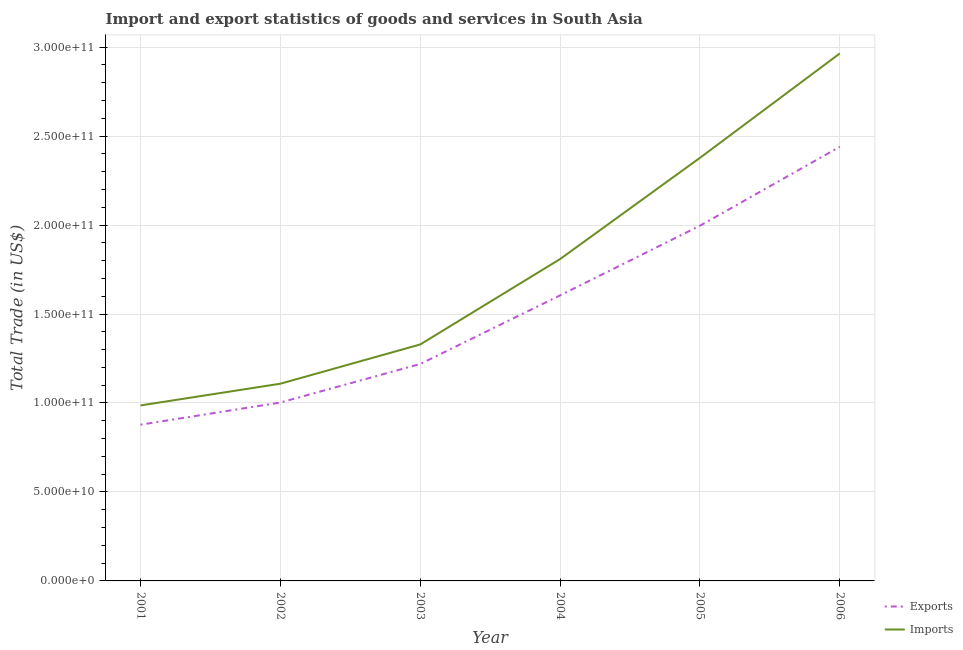How many different coloured lines are there?
Your answer should be compact. 2. Does the line corresponding to imports of goods and services intersect with the line corresponding to export of goods and services?
Keep it short and to the point. No. Is the number of lines equal to the number of legend labels?
Provide a succinct answer. Yes. What is the imports of goods and services in 2002?
Make the answer very short. 1.11e+11. Across all years, what is the maximum imports of goods and services?
Offer a very short reply. 2.96e+11. Across all years, what is the minimum imports of goods and services?
Offer a very short reply. 9.86e+1. In which year was the imports of goods and services maximum?
Your answer should be very brief. 2006. What is the total imports of goods and services in the graph?
Your answer should be compact. 1.06e+12. What is the difference between the imports of goods and services in 2001 and that in 2002?
Offer a very short reply. -1.22e+1. What is the difference between the export of goods and services in 2005 and the imports of goods and services in 2003?
Ensure brevity in your answer.  6.67e+1. What is the average export of goods and services per year?
Make the answer very short. 1.52e+11. In the year 2006, what is the difference between the export of goods and services and imports of goods and services?
Ensure brevity in your answer.  -5.24e+1. What is the ratio of the imports of goods and services in 2001 to that in 2005?
Provide a short and direct response. 0.41. Is the imports of goods and services in 2001 less than that in 2003?
Ensure brevity in your answer.  Yes. Is the difference between the imports of goods and services in 2004 and 2005 greater than the difference between the export of goods and services in 2004 and 2005?
Offer a terse response. No. What is the difference between the highest and the second highest imports of goods and services?
Keep it short and to the point. 5.87e+1. What is the difference between the highest and the lowest imports of goods and services?
Give a very brief answer. 1.98e+11. Does the export of goods and services monotonically increase over the years?
Give a very brief answer. Yes. Are the values on the major ticks of Y-axis written in scientific E-notation?
Offer a terse response. Yes. How are the legend labels stacked?
Give a very brief answer. Vertical. What is the title of the graph?
Give a very brief answer. Import and export statistics of goods and services in South Asia. What is the label or title of the X-axis?
Offer a very short reply. Year. What is the label or title of the Y-axis?
Your answer should be very brief. Total Trade (in US$). What is the Total Trade (in US$) in Exports in 2001?
Provide a short and direct response. 8.78e+1. What is the Total Trade (in US$) in Imports in 2001?
Your answer should be very brief. 9.86e+1. What is the Total Trade (in US$) in Exports in 2002?
Provide a succinct answer. 1.00e+11. What is the Total Trade (in US$) of Imports in 2002?
Provide a short and direct response. 1.11e+11. What is the Total Trade (in US$) in Exports in 2003?
Ensure brevity in your answer.  1.22e+11. What is the Total Trade (in US$) in Imports in 2003?
Make the answer very short. 1.33e+11. What is the Total Trade (in US$) of Exports in 2004?
Your response must be concise. 1.60e+11. What is the Total Trade (in US$) in Imports in 2004?
Make the answer very short. 1.81e+11. What is the Total Trade (in US$) of Exports in 2005?
Your answer should be very brief. 2.00e+11. What is the Total Trade (in US$) in Imports in 2005?
Ensure brevity in your answer.  2.38e+11. What is the Total Trade (in US$) in Exports in 2006?
Keep it short and to the point. 2.44e+11. What is the Total Trade (in US$) of Imports in 2006?
Provide a succinct answer. 2.96e+11. Across all years, what is the maximum Total Trade (in US$) of Exports?
Your answer should be very brief. 2.44e+11. Across all years, what is the maximum Total Trade (in US$) of Imports?
Provide a succinct answer. 2.96e+11. Across all years, what is the minimum Total Trade (in US$) in Exports?
Ensure brevity in your answer.  8.78e+1. Across all years, what is the minimum Total Trade (in US$) of Imports?
Your response must be concise. 9.86e+1. What is the total Total Trade (in US$) in Exports in the graph?
Offer a very short reply. 9.14e+11. What is the total Total Trade (in US$) of Imports in the graph?
Your answer should be compact. 1.06e+12. What is the difference between the Total Trade (in US$) in Exports in 2001 and that in 2002?
Keep it short and to the point. -1.25e+1. What is the difference between the Total Trade (in US$) of Imports in 2001 and that in 2002?
Provide a short and direct response. -1.22e+1. What is the difference between the Total Trade (in US$) in Exports in 2001 and that in 2003?
Offer a terse response. -3.41e+1. What is the difference between the Total Trade (in US$) of Imports in 2001 and that in 2003?
Your response must be concise. -3.43e+1. What is the difference between the Total Trade (in US$) of Exports in 2001 and that in 2004?
Your answer should be compact. -7.27e+1. What is the difference between the Total Trade (in US$) in Imports in 2001 and that in 2004?
Make the answer very short. -8.23e+1. What is the difference between the Total Trade (in US$) in Exports in 2001 and that in 2005?
Make the answer very short. -1.12e+11. What is the difference between the Total Trade (in US$) in Imports in 2001 and that in 2005?
Offer a very short reply. -1.39e+11. What is the difference between the Total Trade (in US$) of Exports in 2001 and that in 2006?
Keep it short and to the point. -1.56e+11. What is the difference between the Total Trade (in US$) of Imports in 2001 and that in 2006?
Ensure brevity in your answer.  -1.98e+11. What is the difference between the Total Trade (in US$) of Exports in 2002 and that in 2003?
Ensure brevity in your answer.  -2.17e+1. What is the difference between the Total Trade (in US$) of Imports in 2002 and that in 2003?
Make the answer very short. -2.20e+1. What is the difference between the Total Trade (in US$) of Exports in 2002 and that in 2004?
Ensure brevity in your answer.  -6.02e+1. What is the difference between the Total Trade (in US$) of Imports in 2002 and that in 2004?
Ensure brevity in your answer.  -7.00e+1. What is the difference between the Total Trade (in US$) in Exports in 2002 and that in 2005?
Your answer should be very brief. -9.93e+1. What is the difference between the Total Trade (in US$) in Imports in 2002 and that in 2005?
Keep it short and to the point. -1.27e+11. What is the difference between the Total Trade (in US$) in Exports in 2002 and that in 2006?
Offer a very short reply. -1.44e+11. What is the difference between the Total Trade (in US$) in Imports in 2002 and that in 2006?
Your answer should be compact. -1.86e+11. What is the difference between the Total Trade (in US$) of Exports in 2003 and that in 2004?
Your response must be concise. -3.86e+1. What is the difference between the Total Trade (in US$) in Imports in 2003 and that in 2004?
Make the answer very short. -4.80e+1. What is the difference between the Total Trade (in US$) of Exports in 2003 and that in 2005?
Provide a succinct answer. -7.77e+1. What is the difference between the Total Trade (in US$) in Imports in 2003 and that in 2005?
Ensure brevity in your answer.  -1.05e+11. What is the difference between the Total Trade (in US$) in Exports in 2003 and that in 2006?
Keep it short and to the point. -1.22e+11. What is the difference between the Total Trade (in US$) in Imports in 2003 and that in 2006?
Offer a terse response. -1.64e+11. What is the difference between the Total Trade (in US$) in Exports in 2004 and that in 2005?
Provide a succinct answer. -3.91e+1. What is the difference between the Total Trade (in US$) of Imports in 2004 and that in 2005?
Give a very brief answer. -5.69e+1. What is the difference between the Total Trade (in US$) of Exports in 2004 and that in 2006?
Make the answer very short. -8.35e+1. What is the difference between the Total Trade (in US$) in Imports in 2004 and that in 2006?
Your response must be concise. -1.16e+11. What is the difference between the Total Trade (in US$) in Exports in 2005 and that in 2006?
Your answer should be compact. -4.44e+1. What is the difference between the Total Trade (in US$) of Imports in 2005 and that in 2006?
Offer a very short reply. -5.87e+1. What is the difference between the Total Trade (in US$) in Exports in 2001 and the Total Trade (in US$) in Imports in 2002?
Offer a very short reply. -2.30e+1. What is the difference between the Total Trade (in US$) in Exports in 2001 and the Total Trade (in US$) in Imports in 2003?
Ensure brevity in your answer.  -4.51e+1. What is the difference between the Total Trade (in US$) of Exports in 2001 and the Total Trade (in US$) of Imports in 2004?
Your answer should be very brief. -9.31e+1. What is the difference between the Total Trade (in US$) in Exports in 2001 and the Total Trade (in US$) in Imports in 2005?
Keep it short and to the point. -1.50e+11. What is the difference between the Total Trade (in US$) of Exports in 2001 and the Total Trade (in US$) of Imports in 2006?
Your answer should be compact. -2.09e+11. What is the difference between the Total Trade (in US$) in Exports in 2002 and the Total Trade (in US$) in Imports in 2003?
Offer a terse response. -3.26e+1. What is the difference between the Total Trade (in US$) of Exports in 2002 and the Total Trade (in US$) of Imports in 2004?
Provide a short and direct response. -8.06e+1. What is the difference between the Total Trade (in US$) of Exports in 2002 and the Total Trade (in US$) of Imports in 2005?
Keep it short and to the point. -1.38e+11. What is the difference between the Total Trade (in US$) of Exports in 2002 and the Total Trade (in US$) of Imports in 2006?
Give a very brief answer. -1.96e+11. What is the difference between the Total Trade (in US$) in Exports in 2003 and the Total Trade (in US$) in Imports in 2004?
Offer a very short reply. -5.90e+1. What is the difference between the Total Trade (in US$) in Exports in 2003 and the Total Trade (in US$) in Imports in 2005?
Give a very brief answer. -1.16e+11. What is the difference between the Total Trade (in US$) of Exports in 2003 and the Total Trade (in US$) of Imports in 2006?
Your answer should be very brief. -1.75e+11. What is the difference between the Total Trade (in US$) in Exports in 2004 and the Total Trade (in US$) in Imports in 2005?
Offer a terse response. -7.73e+1. What is the difference between the Total Trade (in US$) in Exports in 2004 and the Total Trade (in US$) in Imports in 2006?
Offer a terse response. -1.36e+11. What is the difference between the Total Trade (in US$) of Exports in 2005 and the Total Trade (in US$) of Imports in 2006?
Your answer should be very brief. -9.68e+1. What is the average Total Trade (in US$) in Exports per year?
Your answer should be very brief. 1.52e+11. What is the average Total Trade (in US$) of Imports per year?
Provide a short and direct response. 1.76e+11. In the year 2001, what is the difference between the Total Trade (in US$) in Exports and Total Trade (in US$) in Imports?
Give a very brief answer. -1.08e+1. In the year 2002, what is the difference between the Total Trade (in US$) of Exports and Total Trade (in US$) of Imports?
Your answer should be very brief. -1.06e+1. In the year 2003, what is the difference between the Total Trade (in US$) in Exports and Total Trade (in US$) in Imports?
Your answer should be compact. -1.10e+1. In the year 2004, what is the difference between the Total Trade (in US$) in Exports and Total Trade (in US$) in Imports?
Offer a very short reply. -2.04e+1. In the year 2005, what is the difference between the Total Trade (in US$) in Exports and Total Trade (in US$) in Imports?
Ensure brevity in your answer.  -3.82e+1. In the year 2006, what is the difference between the Total Trade (in US$) of Exports and Total Trade (in US$) of Imports?
Keep it short and to the point. -5.24e+1. What is the ratio of the Total Trade (in US$) in Exports in 2001 to that in 2002?
Provide a short and direct response. 0.88. What is the ratio of the Total Trade (in US$) in Imports in 2001 to that in 2002?
Keep it short and to the point. 0.89. What is the ratio of the Total Trade (in US$) in Exports in 2001 to that in 2003?
Make the answer very short. 0.72. What is the ratio of the Total Trade (in US$) of Imports in 2001 to that in 2003?
Give a very brief answer. 0.74. What is the ratio of the Total Trade (in US$) in Exports in 2001 to that in 2004?
Give a very brief answer. 0.55. What is the ratio of the Total Trade (in US$) of Imports in 2001 to that in 2004?
Make the answer very short. 0.55. What is the ratio of the Total Trade (in US$) of Exports in 2001 to that in 2005?
Offer a very short reply. 0.44. What is the ratio of the Total Trade (in US$) of Imports in 2001 to that in 2005?
Your response must be concise. 0.41. What is the ratio of the Total Trade (in US$) in Exports in 2001 to that in 2006?
Provide a succinct answer. 0.36. What is the ratio of the Total Trade (in US$) of Imports in 2001 to that in 2006?
Keep it short and to the point. 0.33. What is the ratio of the Total Trade (in US$) of Exports in 2002 to that in 2003?
Provide a short and direct response. 0.82. What is the ratio of the Total Trade (in US$) in Imports in 2002 to that in 2003?
Offer a very short reply. 0.83. What is the ratio of the Total Trade (in US$) of Exports in 2002 to that in 2004?
Provide a short and direct response. 0.62. What is the ratio of the Total Trade (in US$) of Imports in 2002 to that in 2004?
Your response must be concise. 0.61. What is the ratio of the Total Trade (in US$) of Exports in 2002 to that in 2005?
Your response must be concise. 0.5. What is the ratio of the Total Trade (in US$) of Imports in 2002 to that in 2005?
Offer a very short reply. 0.47. What is the ratio of the Total Trade (in US$) in Exports in 2002 to that in 2006?
Keep it short and to the point. 0.41. What is the ratio of the Total Trade (in US$) of Imports in 2002 to that in 2006?
Offer a terse response. 0.37. What is the ratio of the Total Trade (in US$) in Exports in 2003 to that in 2004?
Provide a short and direct response. 0.76. What is the ratio of the Total Trade (in US$) of Imports in 2003 to that in 2004?
Make the answer very short. 0.73. What is the ratio of the Total Trade (in US$) of Exports in 2003 to that in 2005?
Offer a terse response. 0.61. What is the ratio of the Total Trade (in US$) in Imports in 2003 to that in 2005?
Give a very brief answer. 0.56. What is the ratio of the Total Trade (in US$) of Exports in 2003 to that in 2006?
Give a very brief answer. 0.5. What is the ratio of the Total Trade (in US$) of Imports in 2003 to that in 2006?
Provide a succinct answer. 0.45. What is the ratio of the Total Trade (in US$) in Exports in 2004 to that in 2005?
Your answer should be compact. 0.8. What is the ratio of the Total Trade (in US$) in Imports in 2004 to that in 2005?
Your response must be concise. 0.76. What is the ratio of the Total Trade (in US$) of Exports in 2004 to that in 2006?
Make the answer very short. 0.66. What is the ratio of the Total Trade (in US$) in Imports in 2004 to that in 2006?
Make the answer very short. 0.61. What is the ratio of the Total Trade (in US$) in Exports in 2005 to that in 2006?
Ensure brevity in your answer.  0.82. What is the ratio of the Total Trade (in US$) of Imports in 2005 to that in 2006?
Provide a short and direct response. 0.8. What is the difference between the highest and the second highest Total Trade (in US$) in Exports?
Keep it short and to the point. 4.44e+1. What is the difference between the highest and the second highest Total Trade (in US$) in Imports?
Your answer should be very brief. 5.87e+1. What is the difference between the highest and the lowest Total Trade (in US$) of Exports?
Your response must be concise. 1.56e+11. What is the difference between the highest and the lowest Total Trade (in US$) of Imports?
Ensure brevity in your answer.  1.98e+11. 